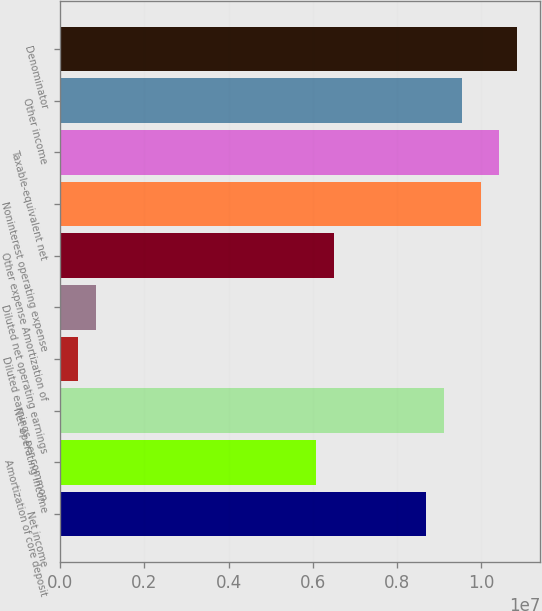Convert chart to OTSL. <chart><loc_0><loc_0><loc_500><loc_500><bar_chart><fcel>Net income<fcel>Amortization of core deposit<fcel>Net operating income<fcel>Diluted earnings per common<fcel>Diluted net operating earnings<fcel>Other expense Amortization of<fcel>Noninterest operating expense<fcel>Taxable-equivalent net<fcel>Other income<fcel>Denominator<nl><fcel>8.67998e+06<fcel>6.07598e+06<fcel>9.11398e+06<fcel>434002<fcel>868000<fcel>6.50998e+06<fcel>9.98197e+06<fcel>1.0416e+07<fcel>9.54797e+06<fcel>1.085e+07<nl></chart> 